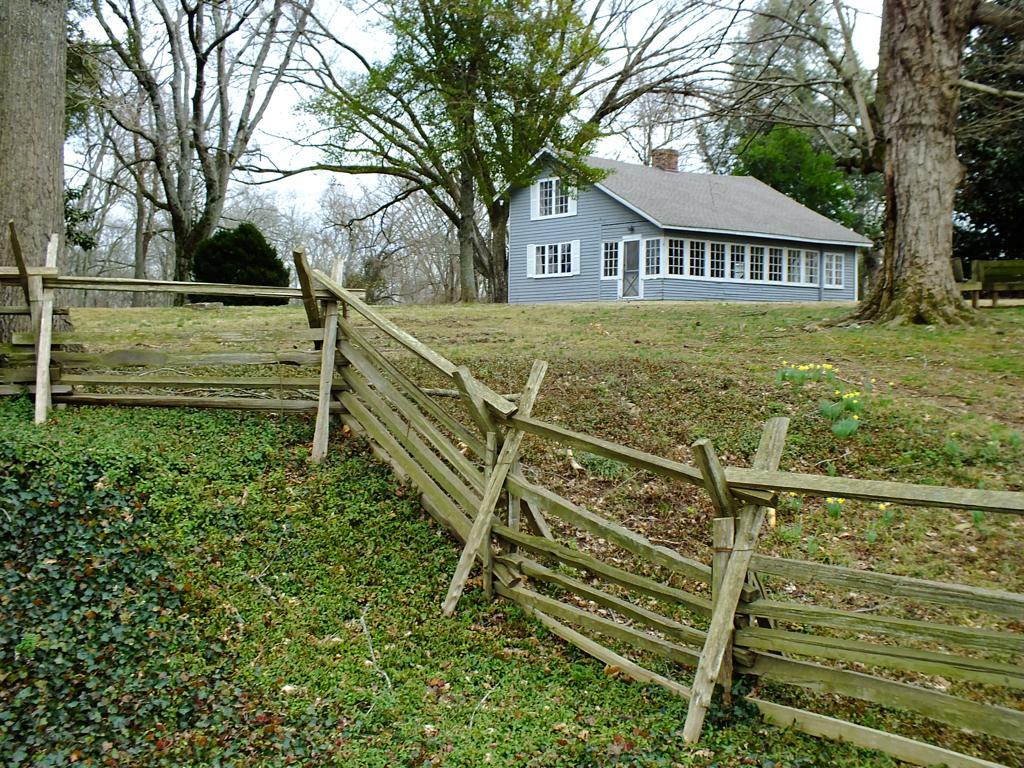In one or two sentences, can you explain what this image depicts? In this image we can see a house with windows and door. And there are trees. And there is a wooden fencing. In the background there is sky. On the ground there are plants. 